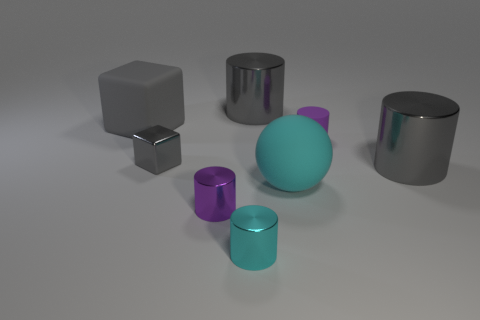Can you infer anything about the purpose of this arrangement of objects? This arrangement of objects might be a part of a 3D rendering or a visual study focusing on form, geometry, and light interaction with surfaces. It could also serve educational purposes, illustrating various shapes and materials for a design or an art class. 